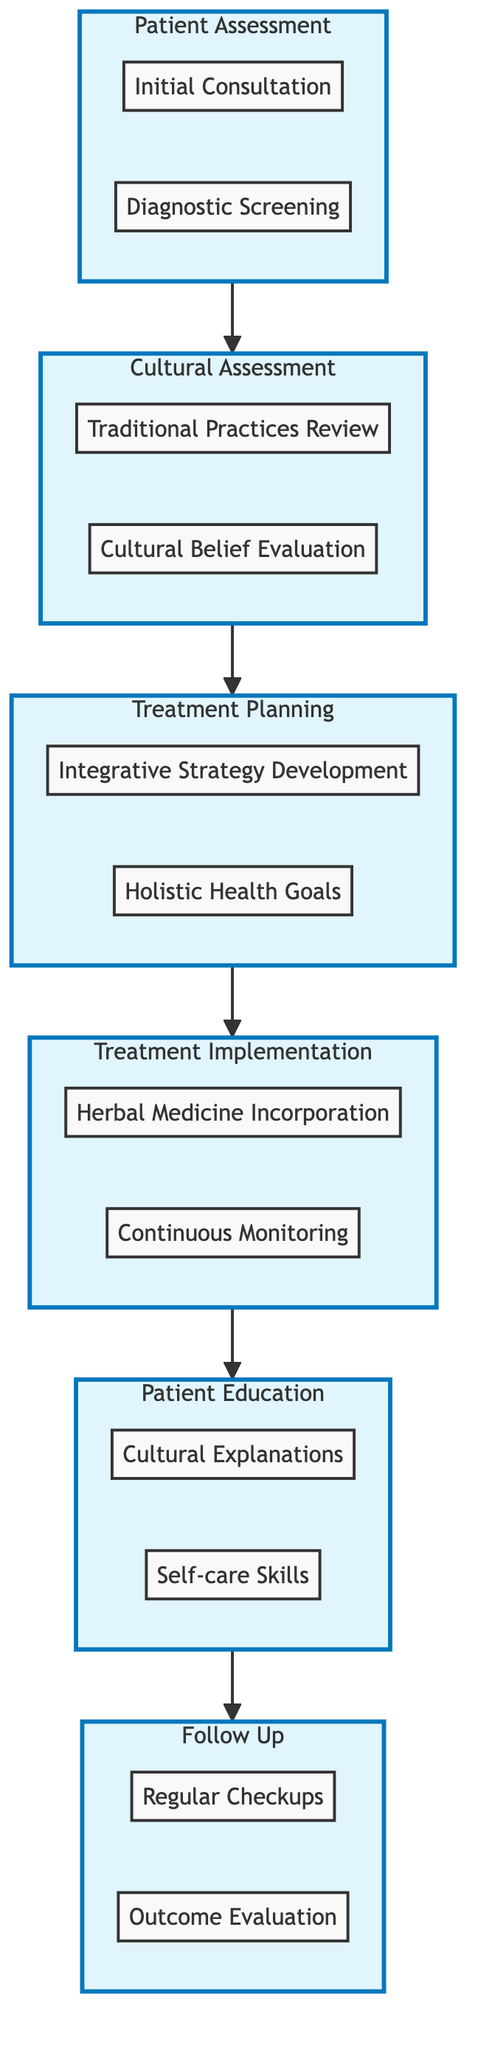What are the elements included in the Patient Assessment? The Patient Assessment includes Initial Consultation and Diagnostic Screening, as shown in the subgraph labeled PA.
Answer: Initial Consultation, Diagnostic Screening How many steps are in the Cultural Assessment? The Cultural Assessment subgraph contains two steps: Traditional Practices Review and Cultural Belief Evaluation.
Answer: 2 What follows after Treatment Implementation? The diagram indicates that Patient Education directly follows Treatment Implementation, indicating a sequential relationship in the pathway.
Answer: Patient Education What is the purpose of the Integrative Strategy Development step? This step aims to develop a strategy that integrates conventional and traditional medicine, ensuring they do not conflict, as stated in the Treatment Planning section.
Answer: Integrative strategy Which assessment identifies traditional medicines or practices used by the patient? Traditional Practices Review is the step that focuses on identifying traditional medicines or practices, thus answering the question based on the Cultural Assessment.
Answer: Traditional Practices Review How does Continuous Monitoring relate to the overall pathway? Continuous Monitoring is part of the Treatment Implementation and emphasizes the need to track patient responses, linking it to the Patient Education and Follow Up phases in the diagram.
Answer: Treatment Implementation What is the output of the pathway after the Patient Education step? The output of following the Patient Education step leads to the Follow Up phase, which includes Regular Checkups and Outcome Evaluation.
Answer: Follow Up What comes before the Holistic Health Goals step? The Integrative Strategy Development step occurs before Holistic Health Goals in the diagram's Treatment Planning subgraph.
Answer: Integrative Strategy Development 